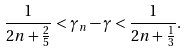<formula> <loc_0><loc_0><loc_500><loc_500>\frac { 1 } { 2 n + \frac { 2 } { 5 } } < \gamma _ { n } - \gamma < \frac { 1 } { 2 n + \frac { 1 } { 3 } } .</formula> 